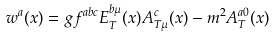<formula> <loc_0><loc_0><loc_500><loc_500>w ^ { a } ( x ) = g f ^ { a b c } E _ { T } ^ { b \mu } ( x ) A _ { T \mu } ^ { c } ( x ) - m ^ { 2 } A _ { T } ^ { a 0 } ( x )</formula> 